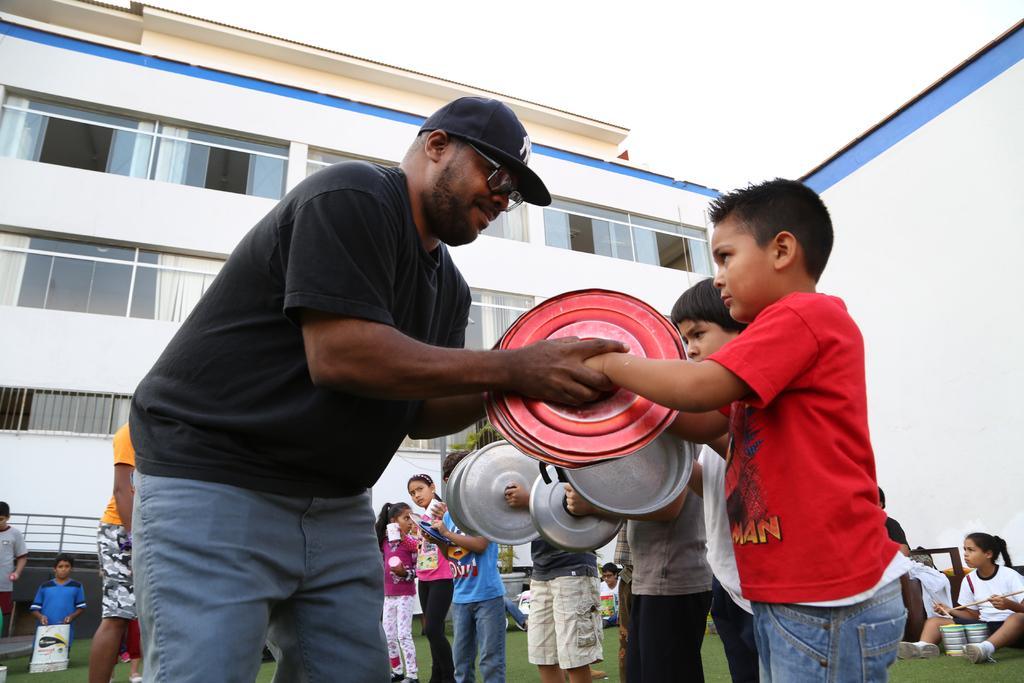How would you summarize this image in a sentence or two? On the right side of the picture there are people. On the left there is a person. In the background there are people. In the background there is a building with glass windows and there are curtains. Sky is cloudy. 